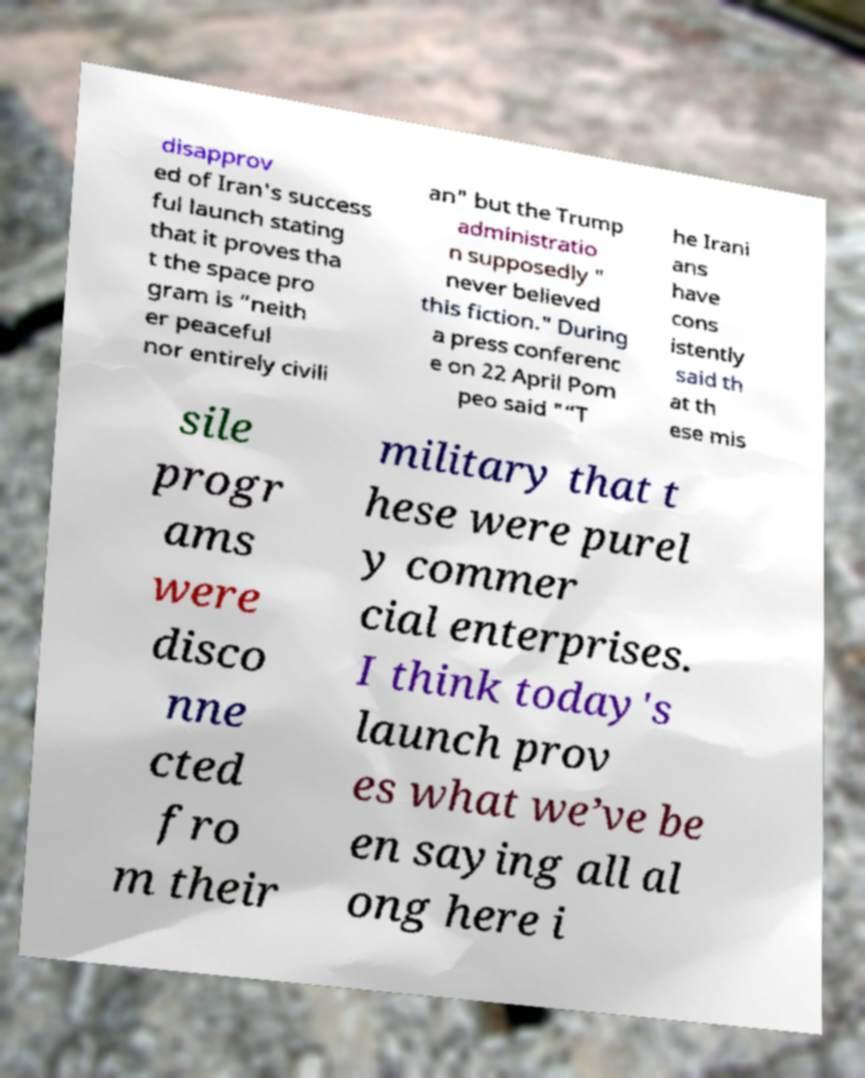I need the written content from this picture converted into text. Can you do that? disapprov ed of Iran's success ful launch stating that it proves tha t the space pro gram is “neith er peaceful nor entirely civili an" but the Trump administratio n supposedly " never believed this fiction." During a press conferenc e on 22 April Pom peo said "“T he Irani ans have cons istently said th at th ese mis sile progr ams were disco nne cted fro m their military that t hese were purel y commer cial enterprises. I think today's launch prov es what we’ve be en saying all al ong here i 